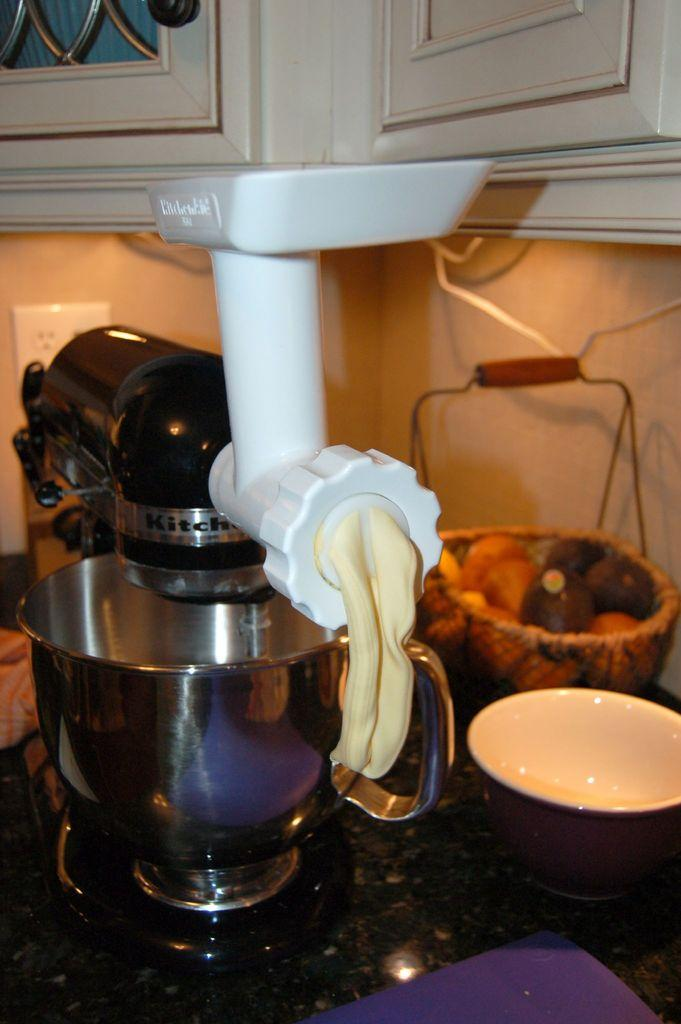<image>
Describe the image concisely. A Kitchen-Aid brand mixer dispensing a creamy looking substance. 